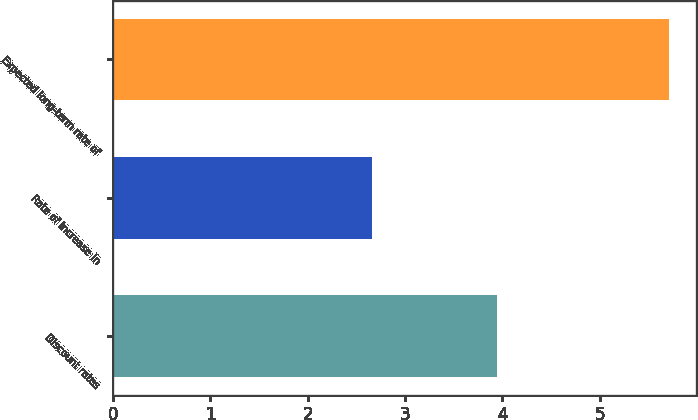Convert chart to OTSL. <chart><loc_0><loc_0><loc_500><loc_500><bar_chart><fcel>Discount rates<fcel>Rate of increase in<fcel>Expected long-term rate of<nl><fcel>3.95<fcel>2.66<fcel>5.71<nl></chart> 